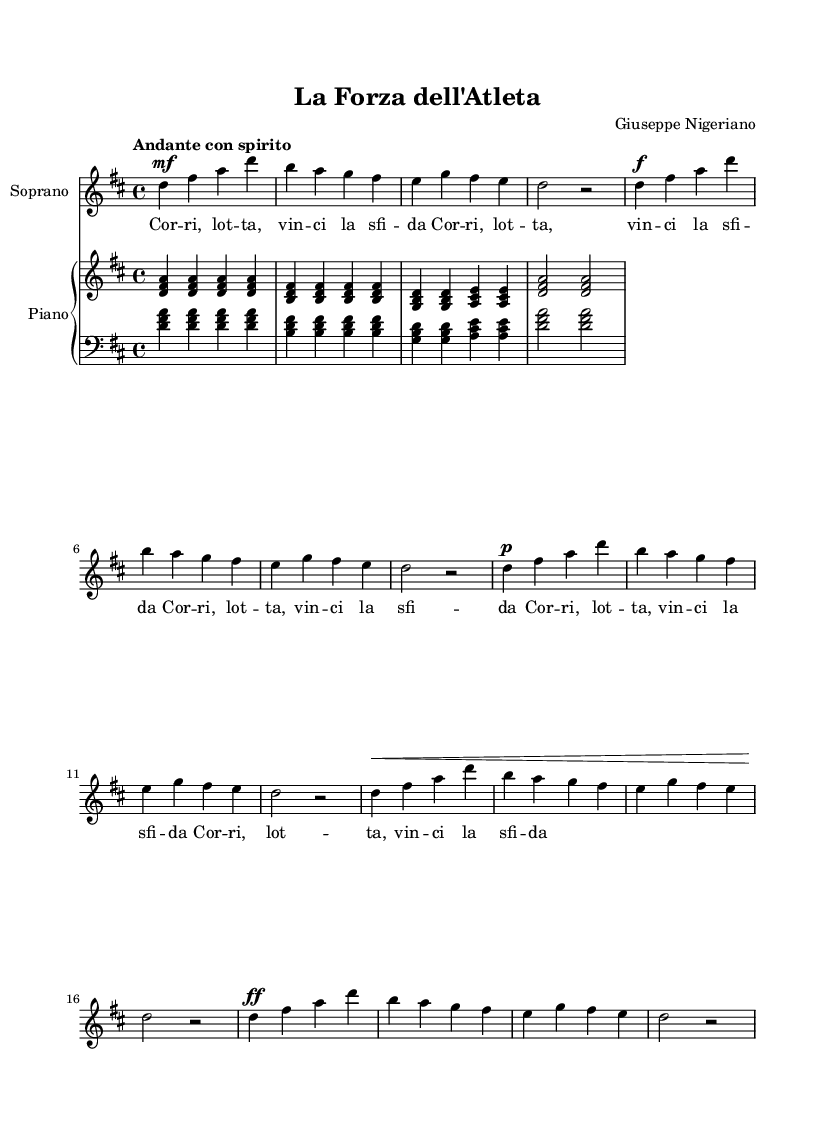What is the key signature of this music? The key signature is indicated at the beginning of the staff. It shows two sharps (F# and C#), which indicates that the piece is in D major.
Answer: D major What is the time signature of this music? The time signature is the fraction found at the beginning of the score, indicating how many beats are in each measure. Here, it is 4/4, meaning there are four beats per measure with a quarter note receiving one beat.
Answer: 4/4 What is the tempo marking for this piece? The tempo marking is located above the staff, telling performers how fast to play. It states "Andante con spirito," which indicates a moderately slow tempo with spirit.
Answer: Andante con spirito How many measures are in the soprano part? Counting the vertical lines (bar lines) indicates divisions of the music into measures. There are 5 measures in the soprano part, each separated by bar lines.
Answer: 5 Which voice type is written in the score? The score specifies the vocal line as "Soprano," which is typically the highest voice part in choir and opera singing.
Answer: Soprano What does the lyric phrase "Corri, lotta, vinci la sfida" translate to in English? The lyric is in Italian, and it translates to "Run, fight, win the challenge," reflecting themes of perseverance and dedication, suitable for athletic pursuits.
Answer: Run, fight, win the challenge What dynamic marking starts the piece? The dynamic marking at the beginning of the soprano part indicates how loudly or softly to sing. The first marking is "mf," which stands for 'mezzo forte,' meaning moderately loud.
Answer: mezzo forte 